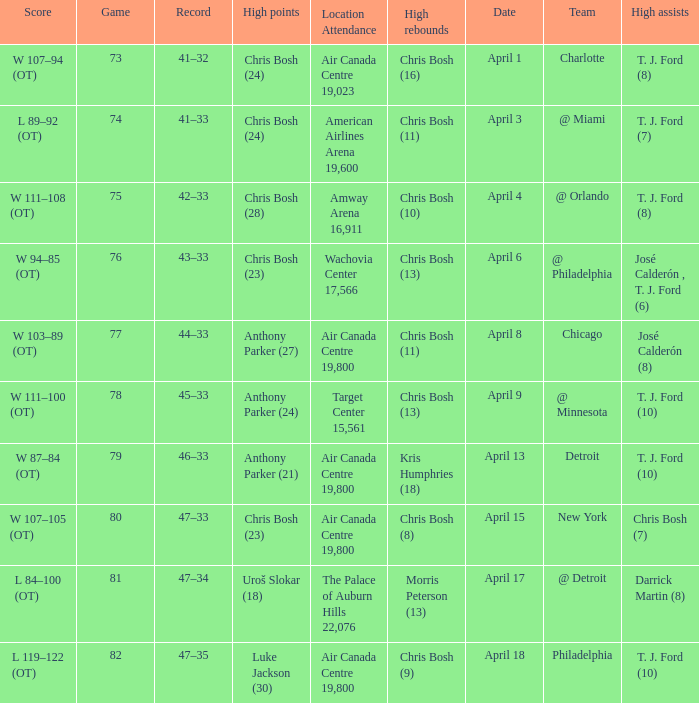I'm looking to parse the entire table for insights. Could you assist me with that? {'header': ['Score', 'Game', 'Record', 'High points', 'Location Attendance', 'High rebounds', 'Date', 'Team', 'High assists'], 'rows': [['W 107–94 (OT)', '73', '41–32', 'Chris Bosh (24)', 'Air Canada Centre 19,023', 'Chris Bosh (16)', 'April 1', 'Charlotte', 'T. J. Ford (8)'], ['L 89–92 (OT)', '74', '41–33', 'Chris Bosh (24)', 'American Airlines Arena 19,600', 'Chris Bosh (11)', 'April 3', '@ Miami', 'T. J. Ford (7)'], ['W 111–108 (OT)', '75', '42–33', 'Chris Bosh (28)', 'Amway Arena 16,911', 'Chris Bosh (10)', 'April 4', '@ Orlando', 'T. J. Ford (8)'], ['W 94–85 (OT)', '76', '43–33', 'Chris Bosh (23)', 'Wachovia Center 17,566', 'Chris Bosh (13)', 'April 6', '@ Philadelphia', 'José Calderón , T. J. Ford (6)'], ['W 103–89 (OT)', '77', '44–33', 'Anthony Parker (27)', 'Air Canada Centre 19,800', 'Chris Bosh (11)', 'April 8', 'Chicago', 'José Calderón (8)'], ['W 111–100 (OT)', '78', '45–33', 'Anthony Parker (24)', 'Target Center 15,561', 'Chris Bosh (13)', 'April 9', '@ Minnesota', 'T. J. Ford (10)'], ['W 87–84 (OT)', '79', '46–33', 'Anthony Parker (21)', 'Air Canada Centre 19,800', 'Kris Humphries (18)', 'April 13', 'Detroit', 'T. J. Ford (10)'], ['W 107–105 (OT)', '80', '47–33', 'Chris Bosh (23)', 'Air Canada Centre 19,800', 'Chris Bosh (8)', 'April 15', 'New York', 'Chris Bosh (7)'], ['L 84–100 (OT)', '81', '47–34', 'Uroš Slokar (18)', 'The Palace of Auburn Hills 22,076', 'Morris Peterson (13)', 'April 17', '@ Detroit', 'Darrick Martin (8)'], ['L 119–122 (OT)', '82', '47–35', 'Luke Jackson (30)', 'Air Canada Centre 19,800', 'Chris Bosh (9)', 'April 18', 'Philadelphia', 'T. J. Ford (10)']]} What were the assists on April 8 in game less than 78? José Calderón (8). 